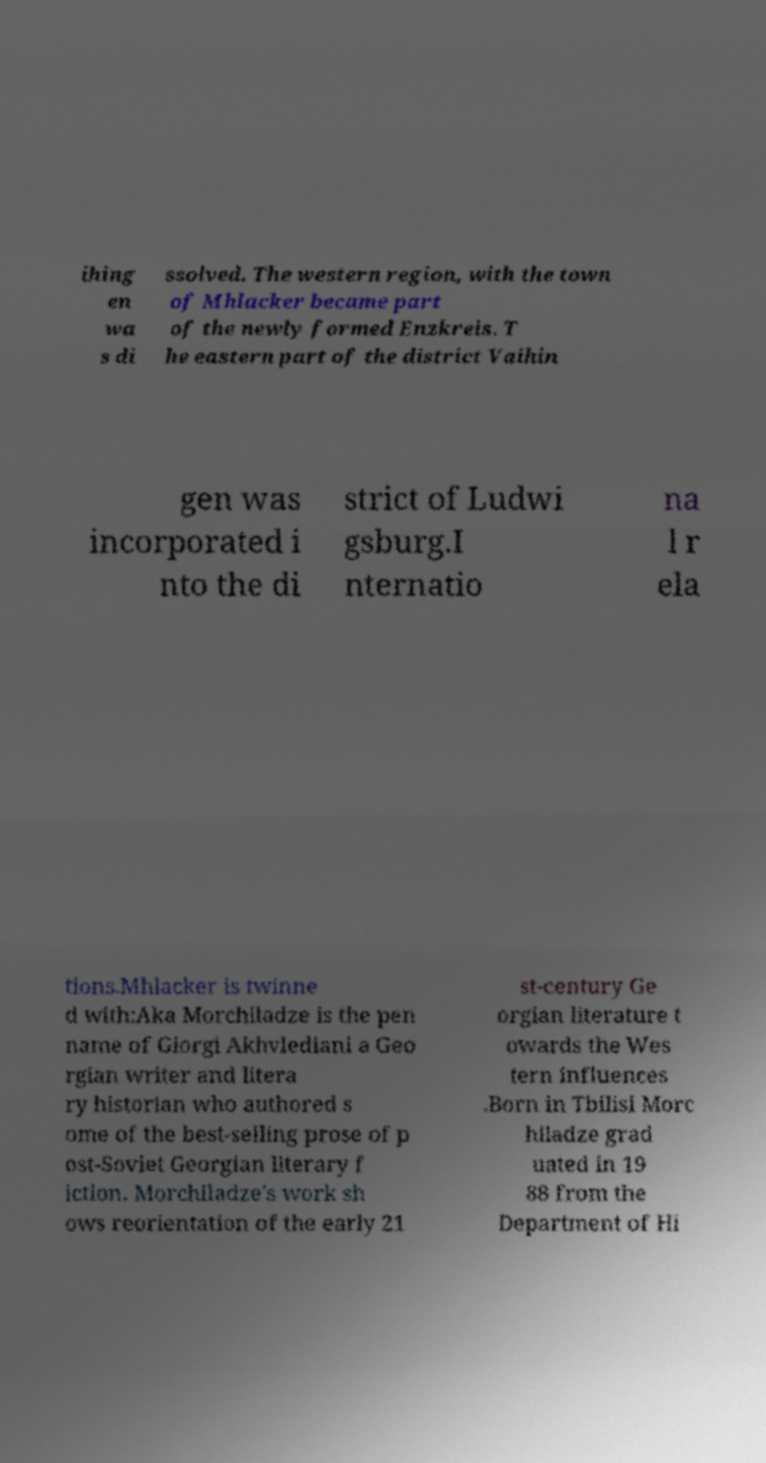Can you accurately transcribe the text from the provided image for me? ihing en wa s di ssolved. The western region, with the town of Mhlacker became part of the newly formed Enzkreis. T he eastern part of the district Vaihin gen was incorporated i nto the di strict of Ludwi gsburg.I nternatio na l r ela tions.Mhlacker is twinne d with:Aka Morchiladze is the pen name of Giorgi Akhvlediani a Geo rgian writer and litera ry historian who authored s ome of the best-selling prose of p ost-Soviet Georgian literary f iction. Morchiladze's work sh ows reorientation of the early 21 st-century Ge orgian literature t owards the Wes tern influences .Born in Tbilisi Morc hiladze grad uated in 19 88 from the Department of Hi 